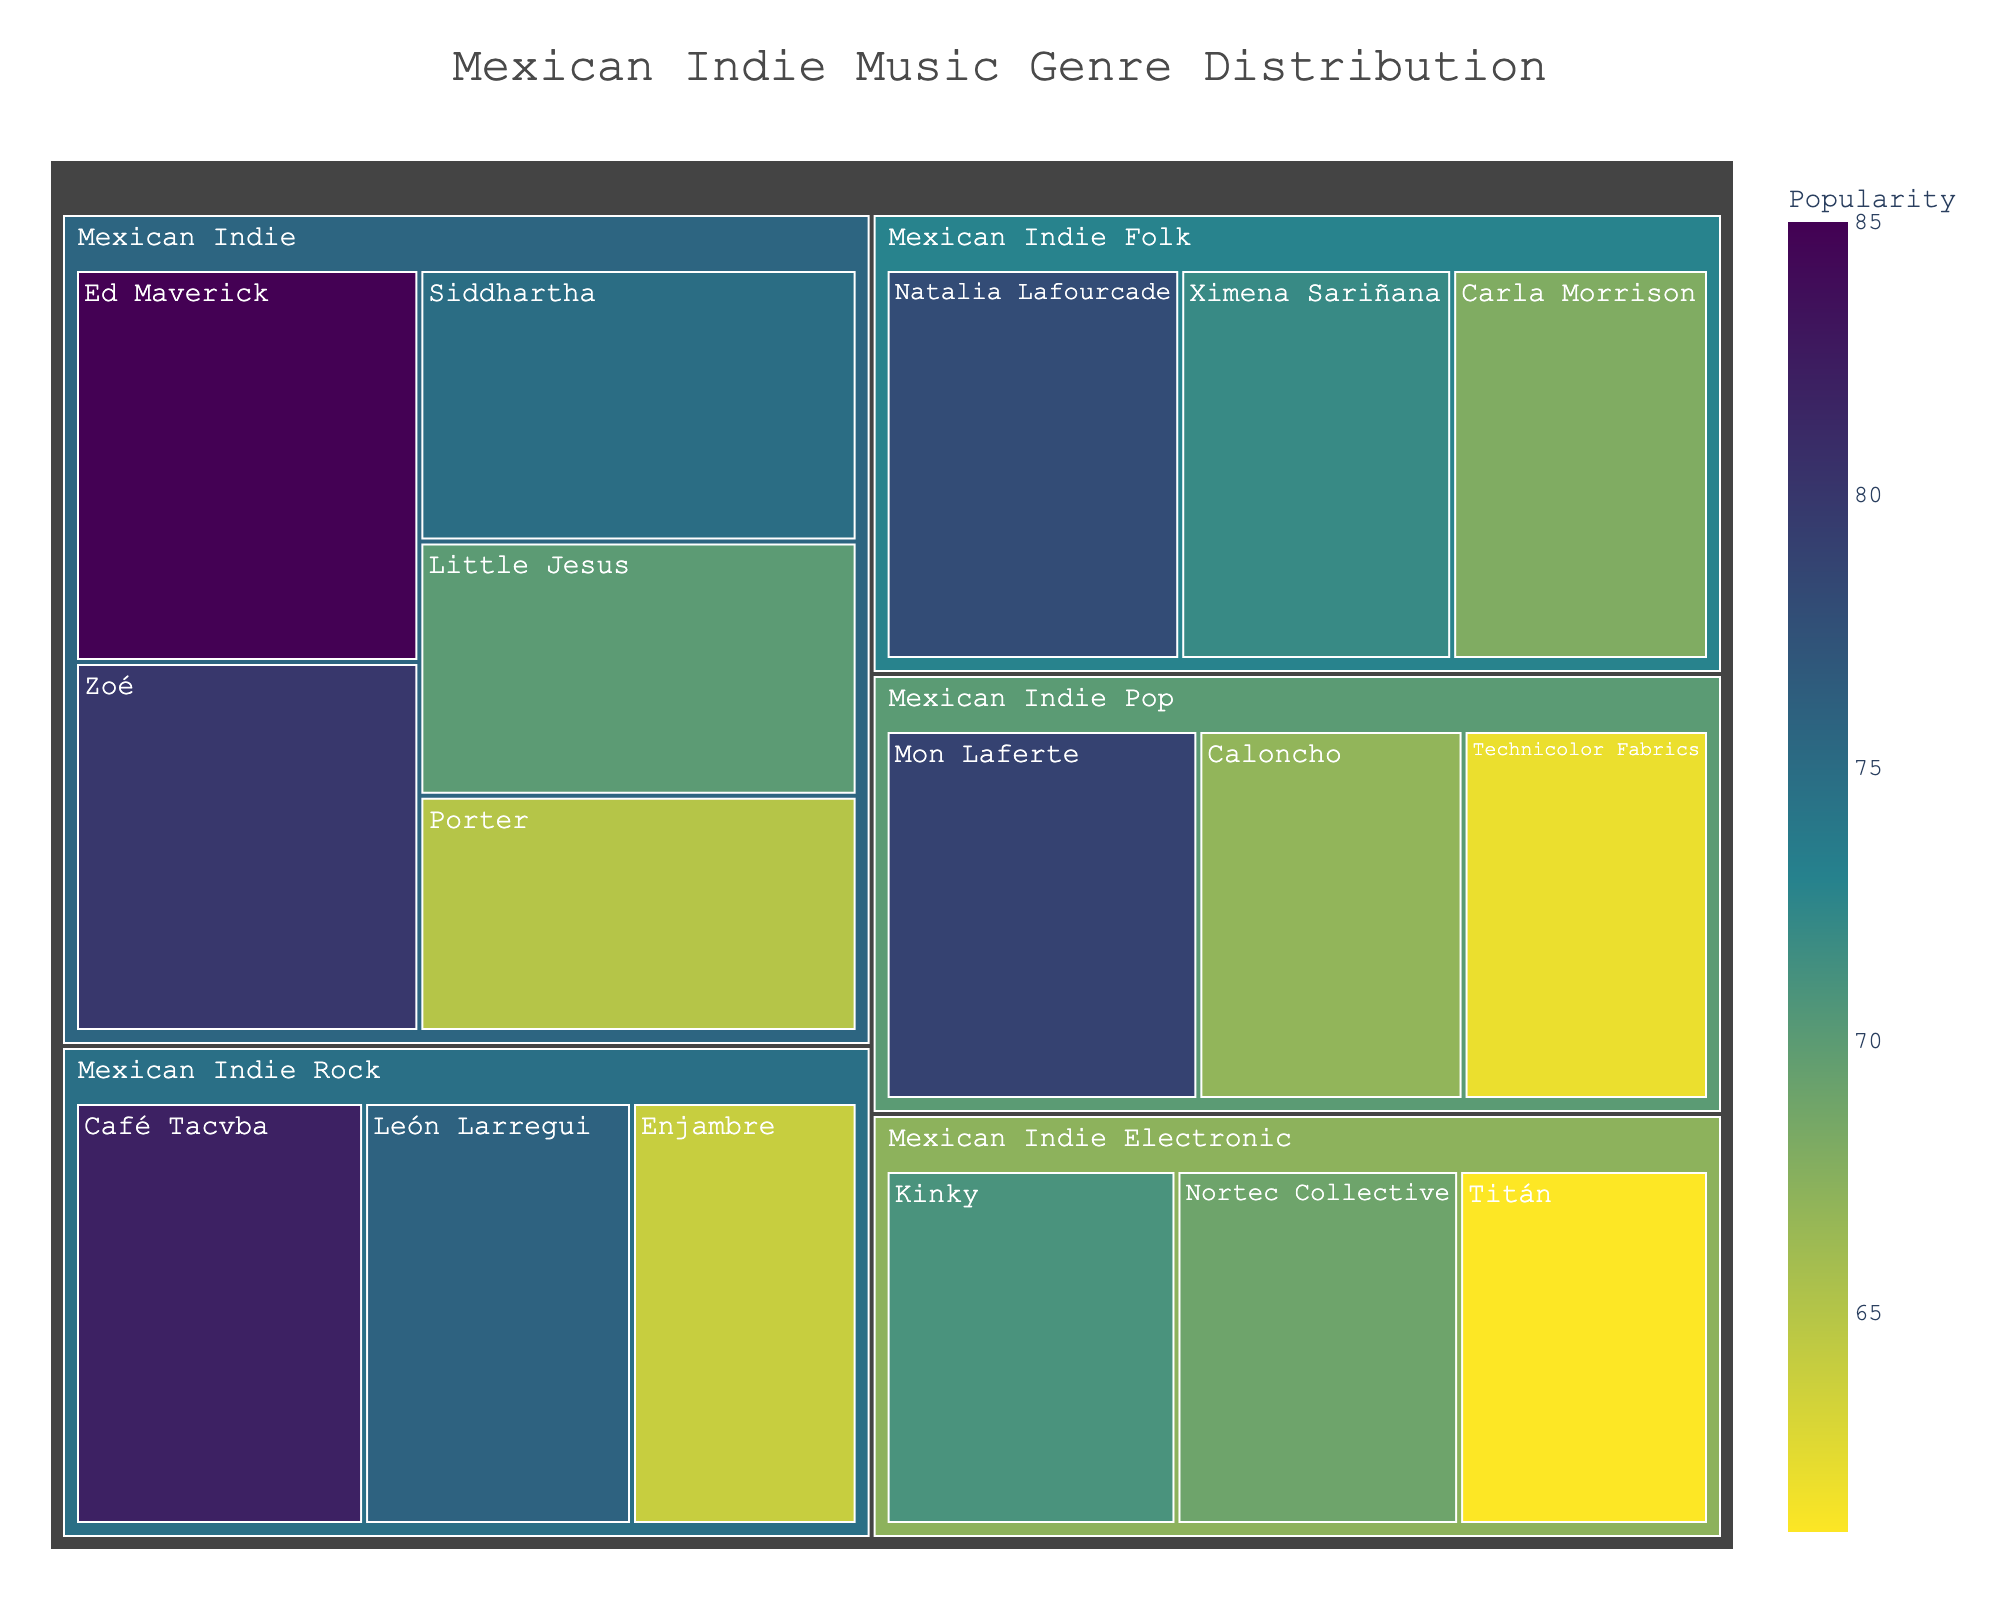what is the subgenre of Ed Maverick? From the treemap, locate the block labeled 'Ed Maverick'. It lies under the 'Mexican Indie' genre.
Answer: Mexican Indie which artist has the highest popularity in the Mexican Indie Pop subgenre? Identify blocks under the 'Mexican Indie Pop' subgenre. Compare their popularity ratings, finding that Mon Laferte has the highest with a popularity of 79.
Answer: Mon Laferte what is the title of the treemap? Observe the chart's title displayed at the top. It reads "Mexican Indie Music Genre Distribution".
Answer: Mexican Indie Music Genre Distribution Which subgenre has more artists: Mexican Indie Folk or Mexican Indie Electronic? Count the number of artists under each subgenre. Mexican Indie Folk has 3 artists (Natalia Lafourcade, Ximena Sariñana, and Carla Morrison), while Mexican Indie Electronic also has 3 (Kinky, Nortec Collective, and Titán). Therefore, they have an equal number of artists.
Answer: Both have 3 artists What is the average popularity of artists in the Mexican Indie Rock subgenre? Locate the Mexican Indie Rock subgenre, then sum up the popularity ratings (82 for Café Tacvba, 76 for León Larregui, and 64 for Enjambre). Divide the total by the number of artists. (82+76+64)/3 = 222/3 = 74.
Answer: 74 Which subgenre has the least popular artist, and who is it? Identify the blocks with the lowest popularity value under each subgenre. The smallest popularity value is 61, found in the Mexican Indie Electronic subgenre for the artist Titán.
Answer: Mexican Indie Electronic, Titán Between Siddhartha and Carla Morrison, who has a higher popularity, and by how much? Compare the popularity ratings of Siddhartha (75) and Carla Morrison (68). Subtract Carla’s popularity from Siddhartha’s to find the difference: 75 - 68 = 7.
Answer: Siddhartha by 7 